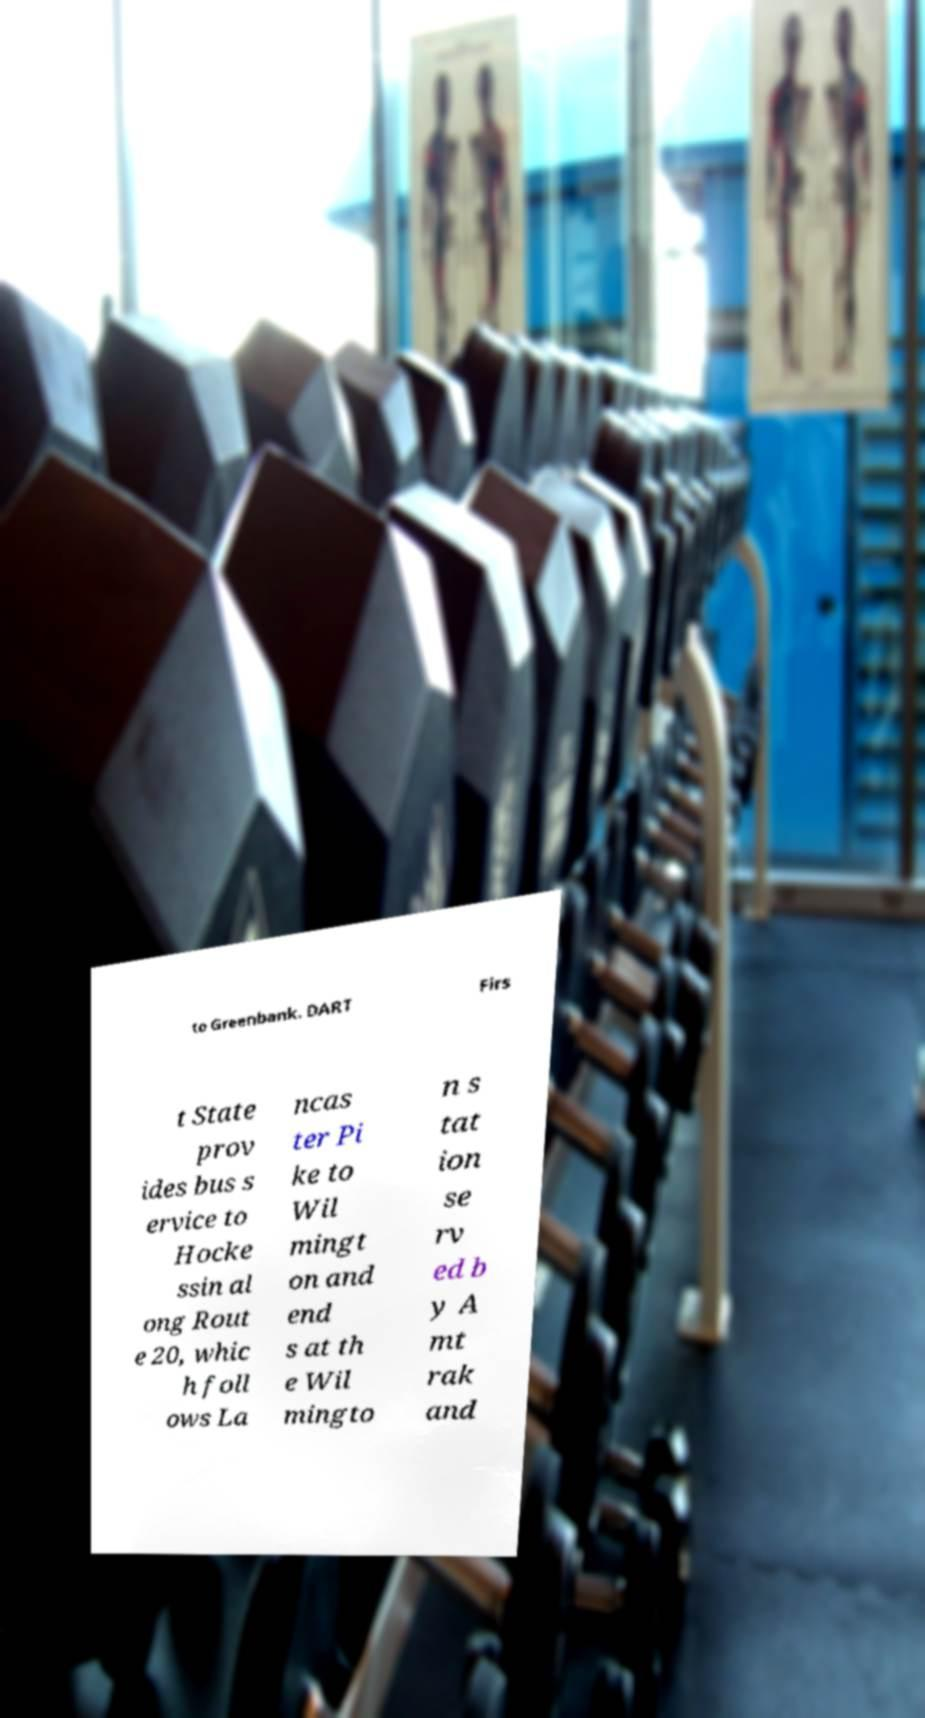Could you assist in decoding the text presented in this image and type it out clearly? to Greenbank. DART Firs t State prov ides bus s ervice to Hocke ssin al ong Rout e 20, whic h foll ows La ncas ter Pi ke to Wil mingt on and end s at th e Wil mingto n s tat ion se rv ed b y A mt rak and 